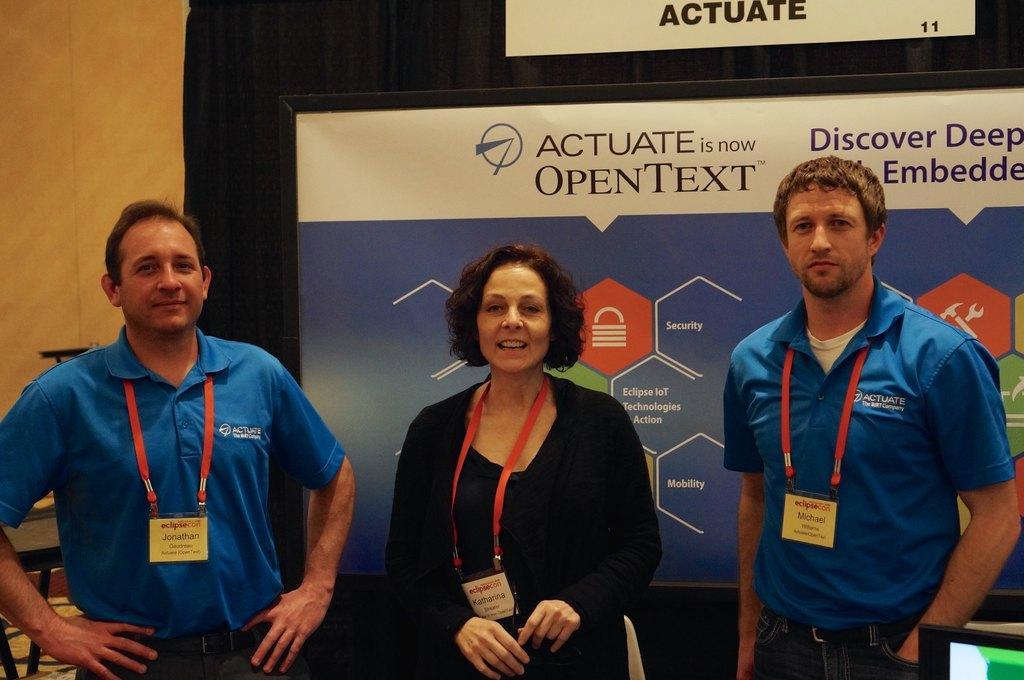How would you summarize this image in a sentence or two? In this image there are two men and one woman standing, and woman is talking and they are wearing tags. In the background there are boards, on the boards there is text and curtain and wall. In the bottom right hand corner there is screen, and in the background there are some objects. 